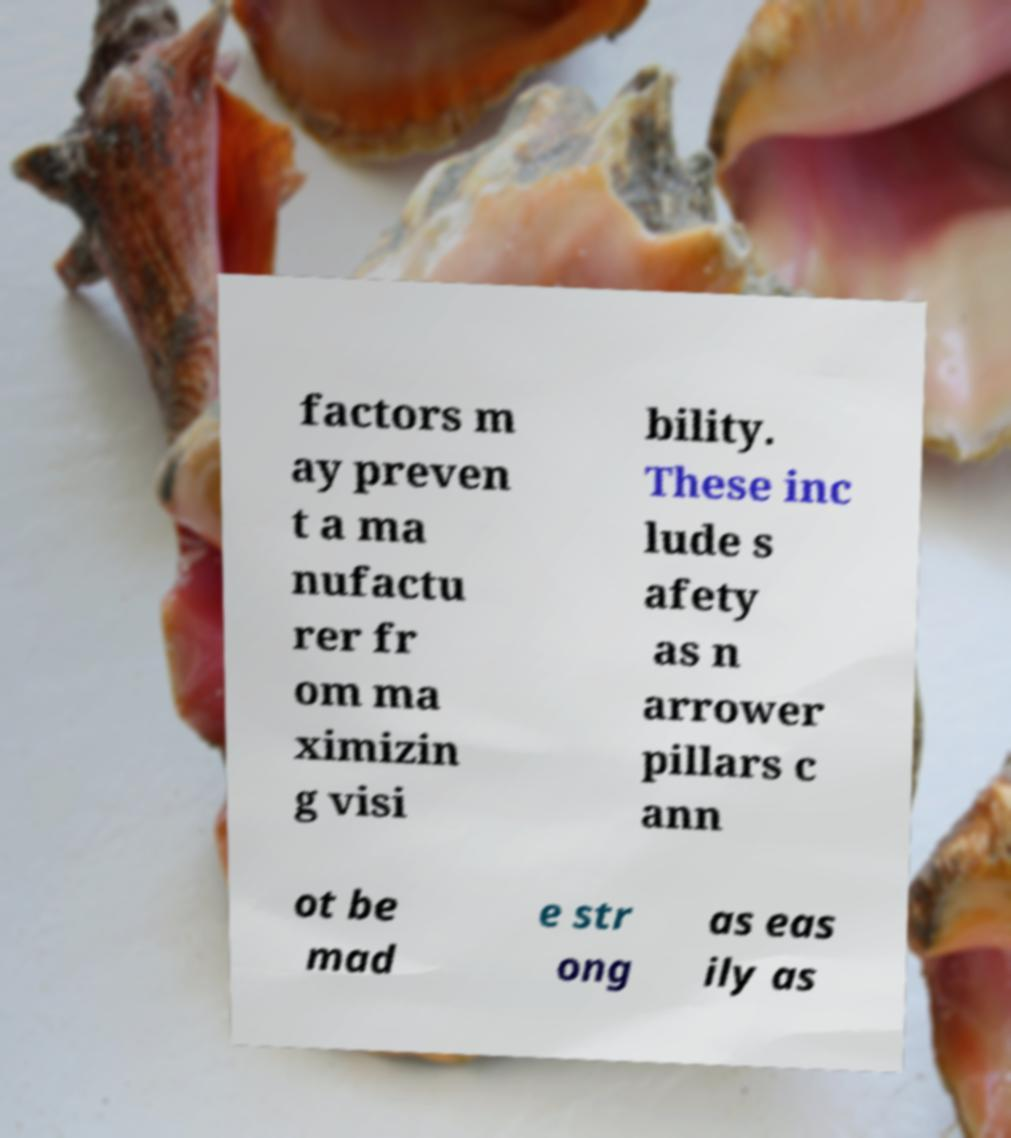Please identify and transcribe the text found in this image. factors m ay preven t a ma nufactu rer fr om ma ximizin g visi bility. These inc lude s afety as n arrower pillars c ann ot be mad e str ong as eas ily as 